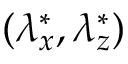<formula> <loc_0><loc_0><loc_500><loc_500>( { \lambda } _ { x } ^ { * } , { \lambda } _ { z } ^ { * } )</formula> 